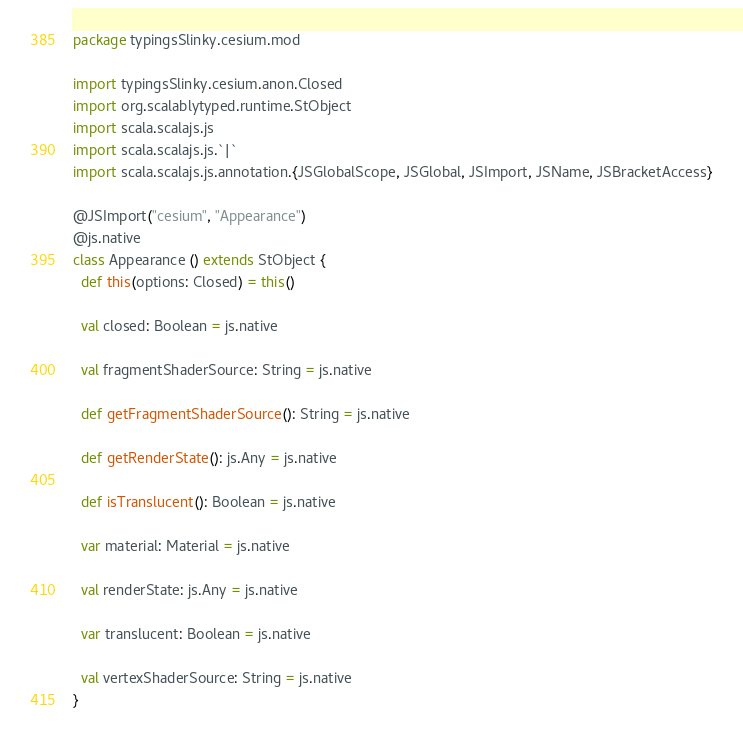Convert code to text. <code><loc_0><loc_0><loc_500><loc_500><_Scala_>package typingsSlinky.cesium.mod

import typingsSlinky.cesium.anon.Closed
import org.scalablytyped.runtime.StObject
import scala.scalajs.js
import scala.scalajs.js.`|`
import scala.scalajs.js.annotation.{JSGlobalScope, JSGlobal, JSImport, JSName, JSBracketAccess}

@JSImport("cesium", "Appearance")
@js.native
class Appearance () extends StObject {
  def this(options: Closed) = this()
  
  val closed: Boolean = js.native
  
  val fragmentShaderSource: String = js.native
  
  def getFragmentShaderSource(): String = js.native
  
  def getRenderState(): js.Any = js.native
  
  def isTranslucent(): Boolean = js.native
  
  var material: Material = js.native
  
  val renderState: js.Any = js.native
  
  var translucent: Boolean = js.native
  
  val vertexShaderSource: String = js.native
}
</code> 